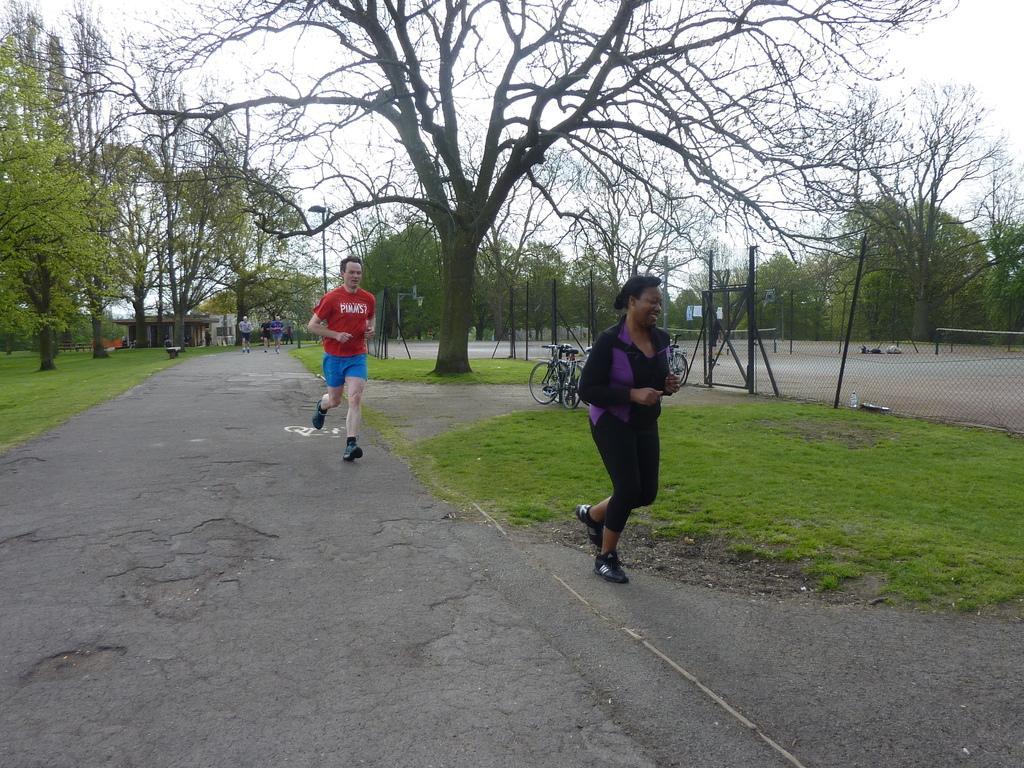Describe this image in one or two sentences. In this image I can see some people running on the road, beside them there are some trees, grass and also there is a fence around the ground. 